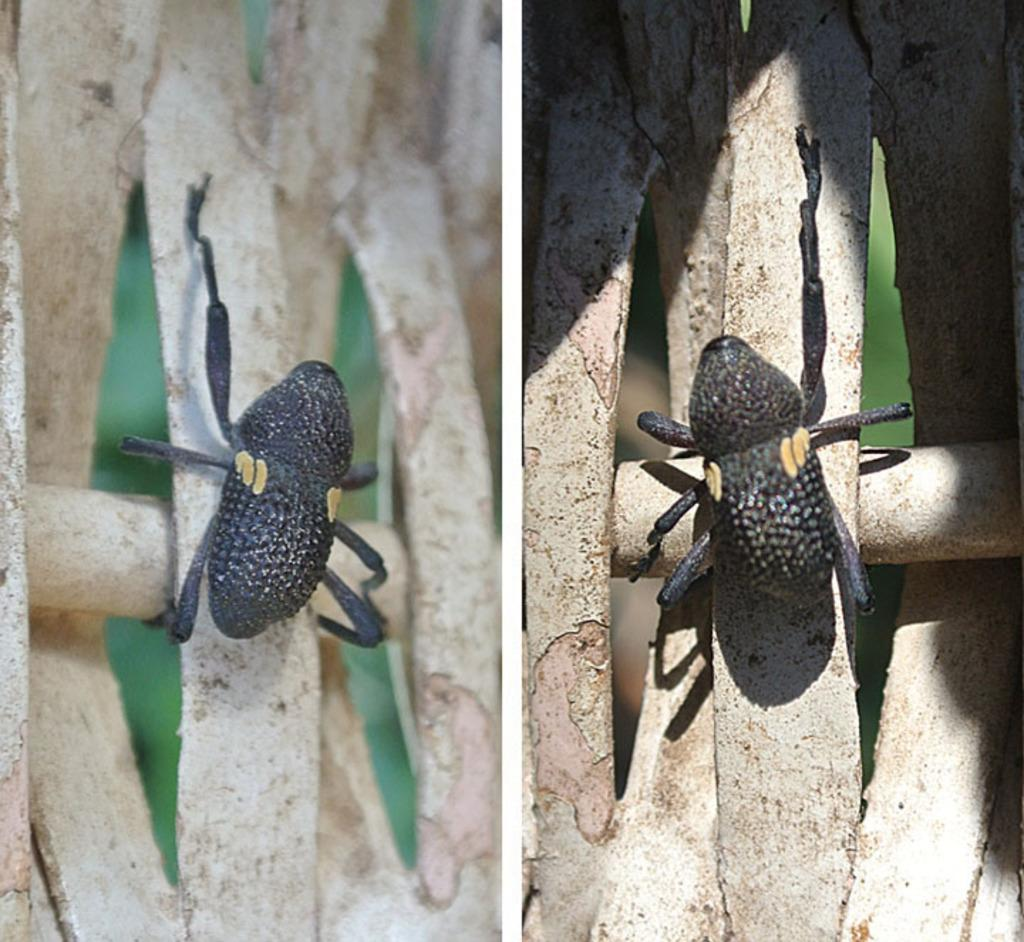What is the composition of the image? The image is a collage of two images. What type of creatures can be seen in the image? There are insects in the image. Where are the insects located in the image? The insects are on the branch of a tree. What type of faucet can be seen in the image? There is no faucet present in the image. How does the system of insects interact with each other in the image? The image does not depict a system of insects interacting with each other; it simply shows insects on a branch. 